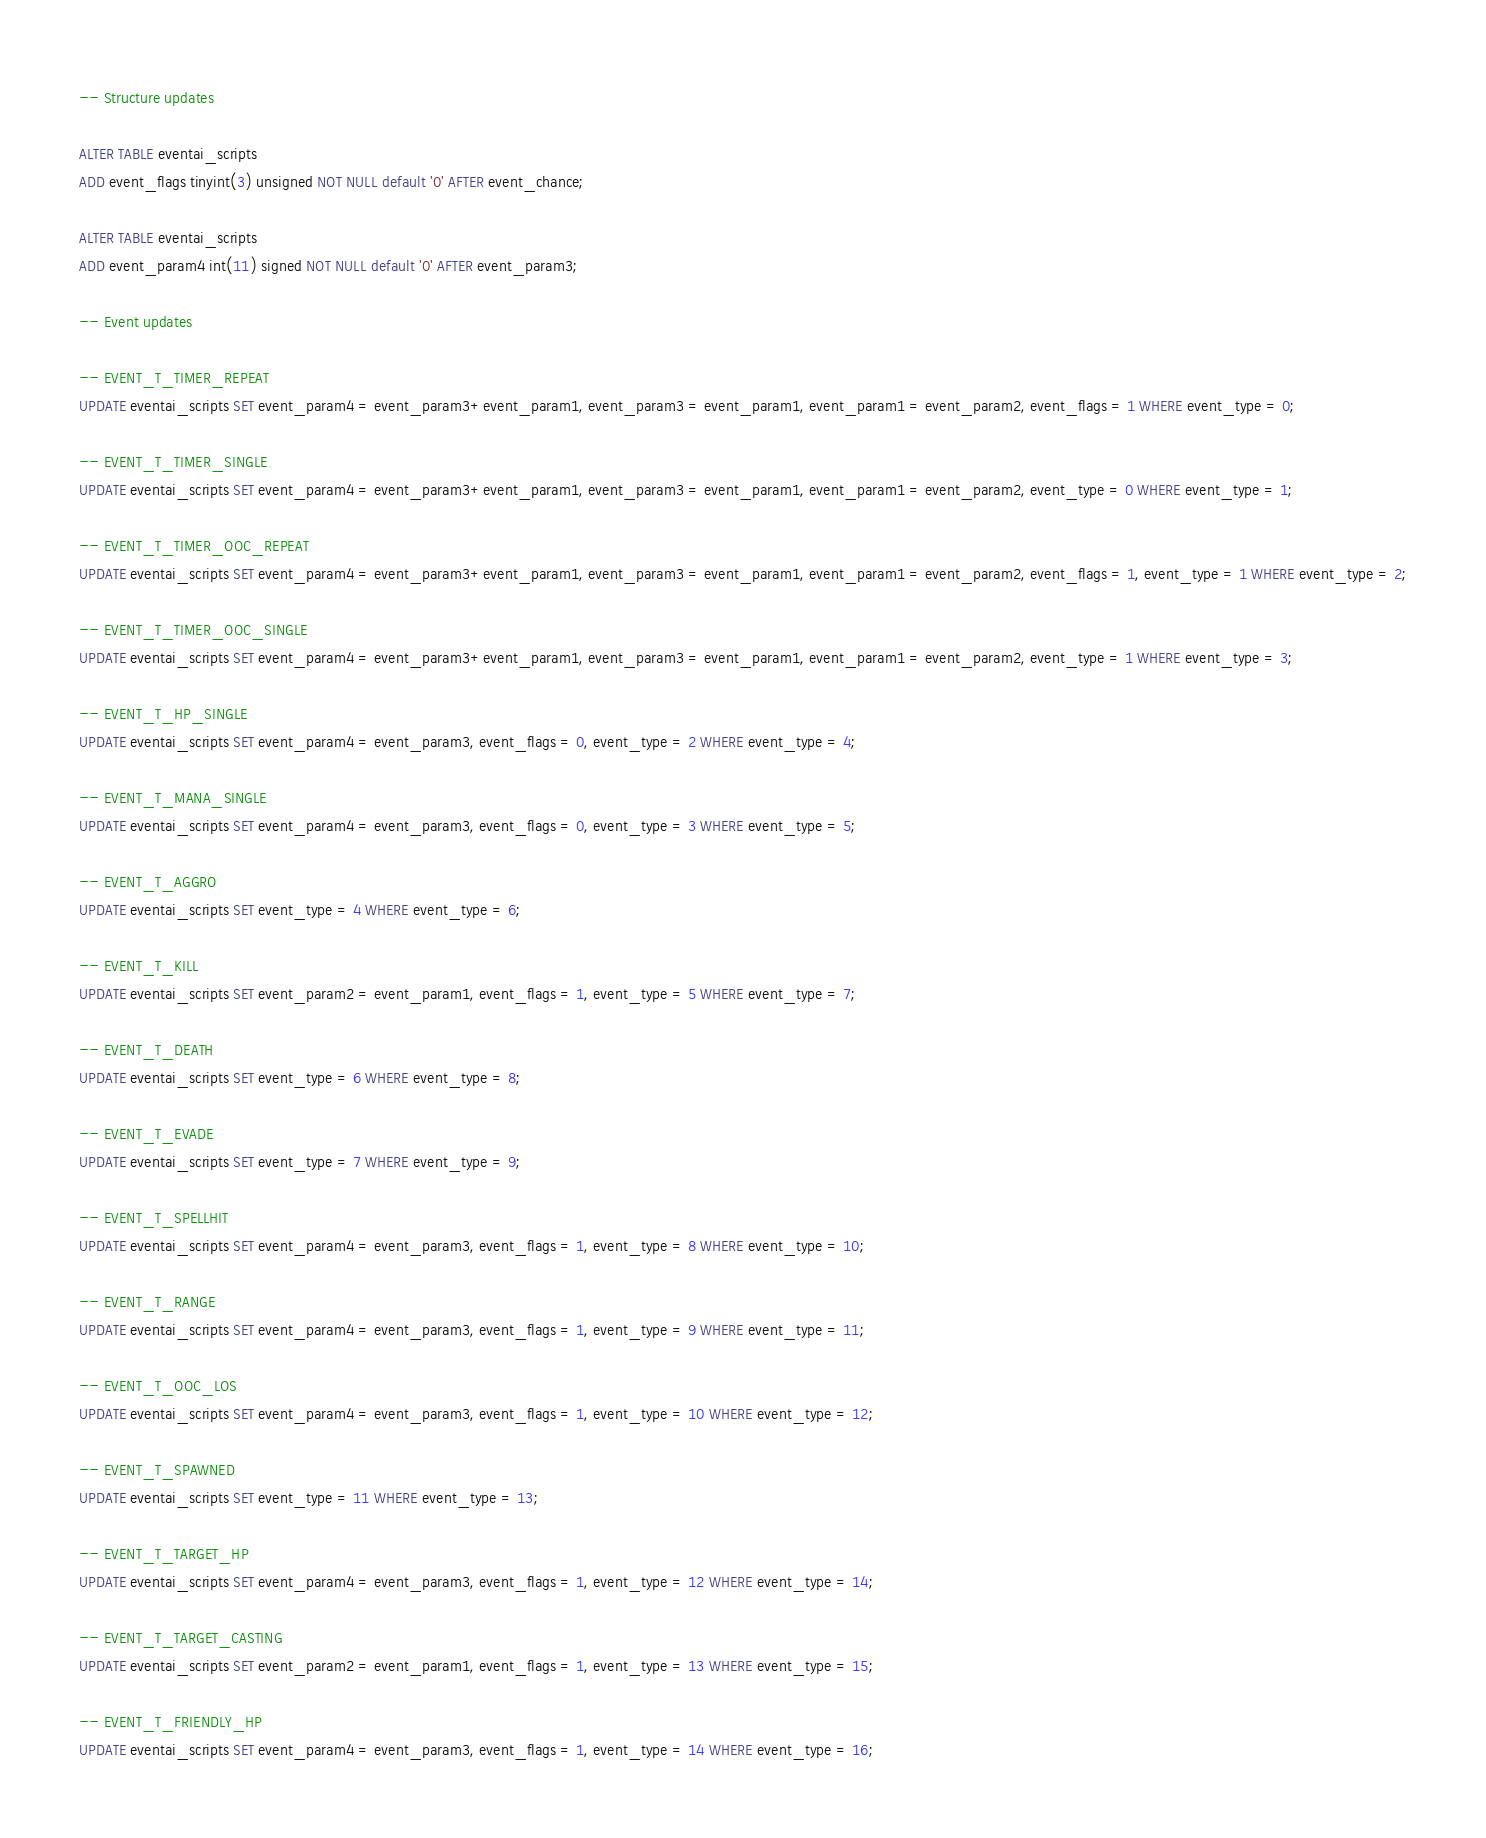<code> <loc_0><loc_0><loc_500><loc_500><_SQL_>-- Structure updates

ALTER TABLE eventai_scripts
ADD event_flags tinyint(3) unsigned NOT NULL default '0' AFTER event_chance;

ALTER TABLE eventai_scripts
ADD event_param4 int(11) signed NOT NULL default '0' AFTER event_param3;

-- Event updates

-- EVENT_T_TIMER_REPEAT
UPDATE eventai_scripts SET event_param4 = event_param3+event_param1, event_param3 = event_param1, event_param1 = event_param2, event_flags = 1 WHERE event_type = 0;

-- EVENT_T_TIMER_SINGLE
UPDATE eventai_scripts SET event_param4 = event_param3+event_param1, event_param3 = event_param1, event_param1 = event_param2, event_type = 0 WHERE event_type = 1;

-- EVENT_T_TIMER_OOC_REPEAT
UPDATE eventai_scripts SET event_param4 = event_param3+event_param1, event_param3 = event_param1, event_param1 = event_param2, event_flags = 1, event_type = 1 WHERE event_type = 2;

-- EVENT_T_TIMER_OOC_SINGLE
UPDATE eventai_scripts SET event_param4 = event_param3+event_param1, event_param3 = event_param1, event_param1 = event_param2, event_type = 1 WHERE event_type = 3;

-- EVENT_T_HP_SINGLE
UPDATE eventai_scripts SET event_param4 = event_param3, event_flags = 0, event_type = 2 WHERE event_type = 4;

-- EVENT_T_MANA_SINGLE
UPDATE eventai_scripts SET event_param4 = event_param3, event_flags = 0, event_type = 3 WHERE event_type = 5;

-- EVENT_T_AGGRO
UPDATE eventai_scripts SET event_type = 4 WHERE event_type = 6;

-- EVENT_T_KILL
UPDATE eventai_scripts SET event_param2 = event_param1, event_flags = 1, event_type = 5 WHERE event_type = 7;

-- EVENT_T_DEATH
UPDATE eventai_scripts SET event_type = 6 WHERE event_type = 8;

-- EVENT_T_EVADE
UPDATE eventai_scripts SET event_type = 7 WHERE event_type = 9;

-- EVENT_T_SPELLHIT
UPDATE eventai_scripts SET event_param4 = event_param3, event_flags = 1, event_type = 8 WHERE event_type = 10;

-- EVENT_T_RANGE
UPDATE eventai_scripts SET event_param4 = event_param3, event_flags = 1, event_type = 9 WHERE event_type = 11;

-- EVENT_T_OOC_LOS
UPDATE eventai_scripts SET event_param4 = event_param3, event_flags = 1, event_type = 10 WHERE event_type = 12;

-- EVENT_T_SPAWNED
UPDATE eventai_scripts SET event_type = 11 WHERE event_type = 13;

-- EVENT_T_TARGET_HP
UPDATE eventai_scripts SET event_param4 = event_param3, event_flags = 1, event_type = 12 WHERE event_type = 14;

-- EVENT_T_TARGET_CASTING
UPDATE eventai_scripts SET event_param2 = event_param1, event_flags = 1, event_type = 13 WHERE event_type = 15;

-- EVENT_T_FRIENDLY_HP
UPDATE eventai_scripts SET event_param4 = event_param3, event_flags = 1, event_type = 14 WHERE event_type = 16;</code> 